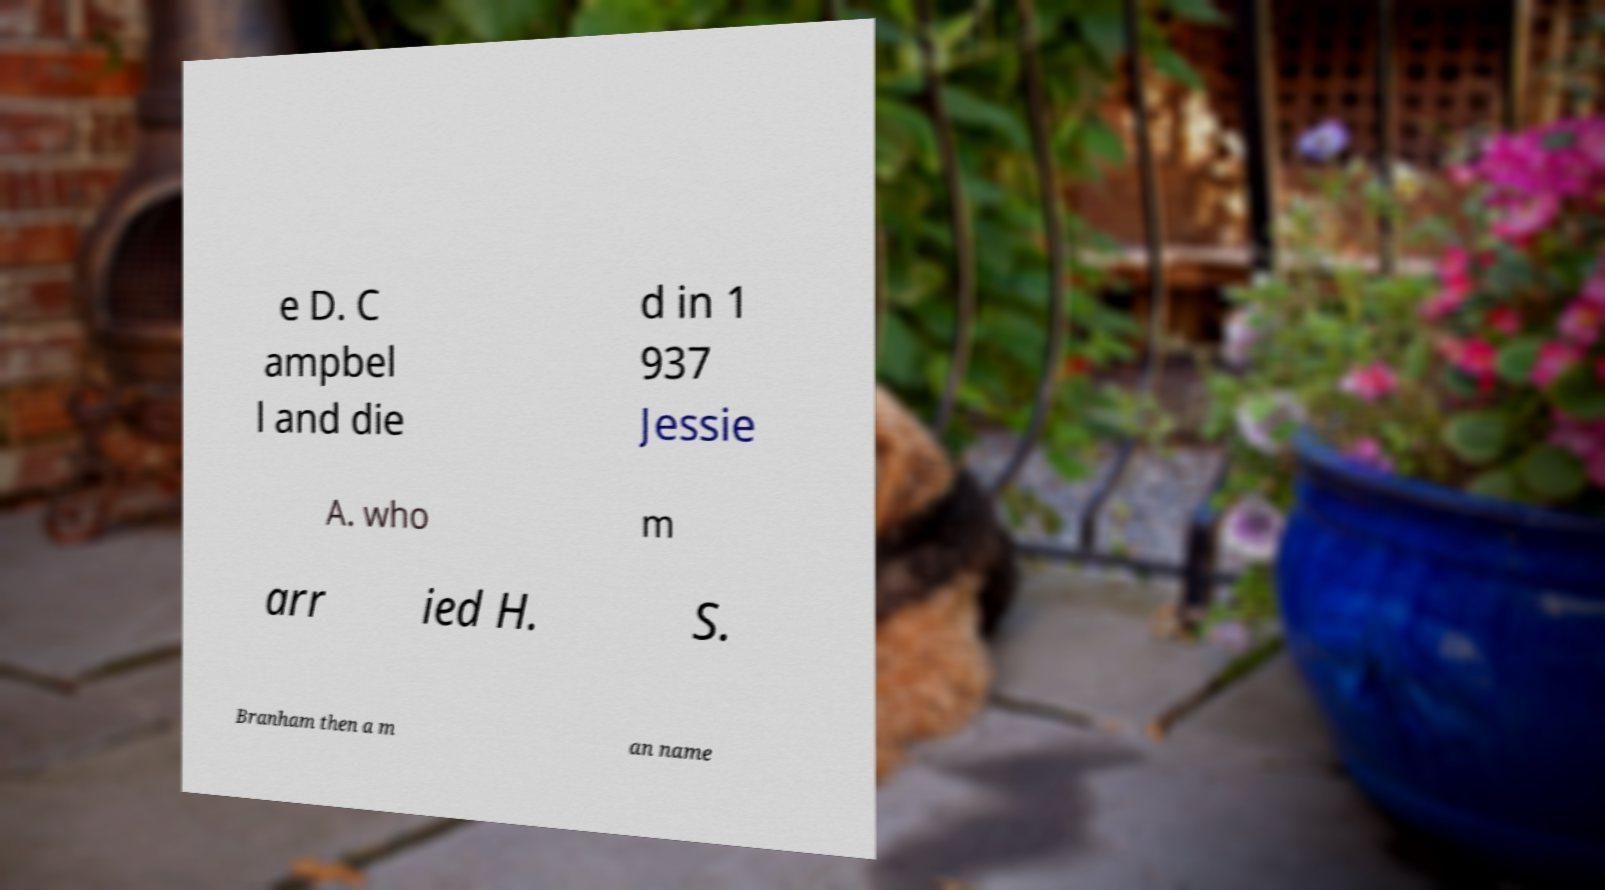There's text embedded in this image that I need extracted. Can you transcribe it verbatim? e D. C ampbel l and die d in 1 937 Jessie A. who m arr ied H. S. Branham then a m an name 